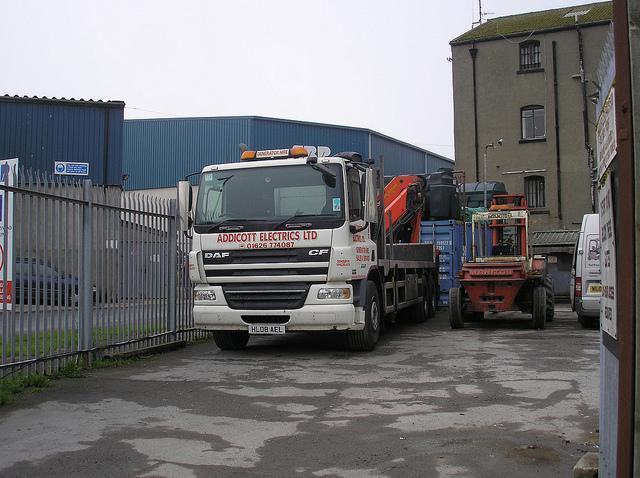How many trucks are there?
Give a very brief answer. 2. How many people are carrying opened umbrellas?
Give a very brief answer. 0. 